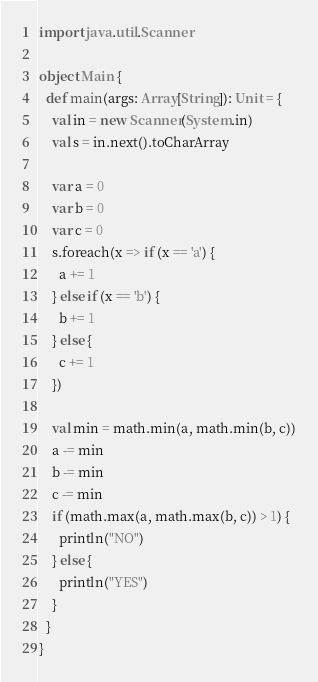<code> <loc_0><loc_0><loc_500><loc_500><_Scala_>import java.util.Scanner

object Main {
  def main(args: Array[String]): Unit = {
    val in = new Scanner(System.in)
    val s = in.next().toCharArray

    var a = 0
    var b = 0
    var c = 0
    s.foreach(x => if (x == 'a') {
      a += 1
    } else if (x == 'b') {
      b += 1
    } else {
      c += 1
    })

    val min = math.min(a, math.min(b, c))
    a -= min
    b -= min
    c -= min
    if (math.max(a, math.max(b, c)) > 1) {
      println("NO")
    } else {
      println("YES")
    }
  }
}
</code> 